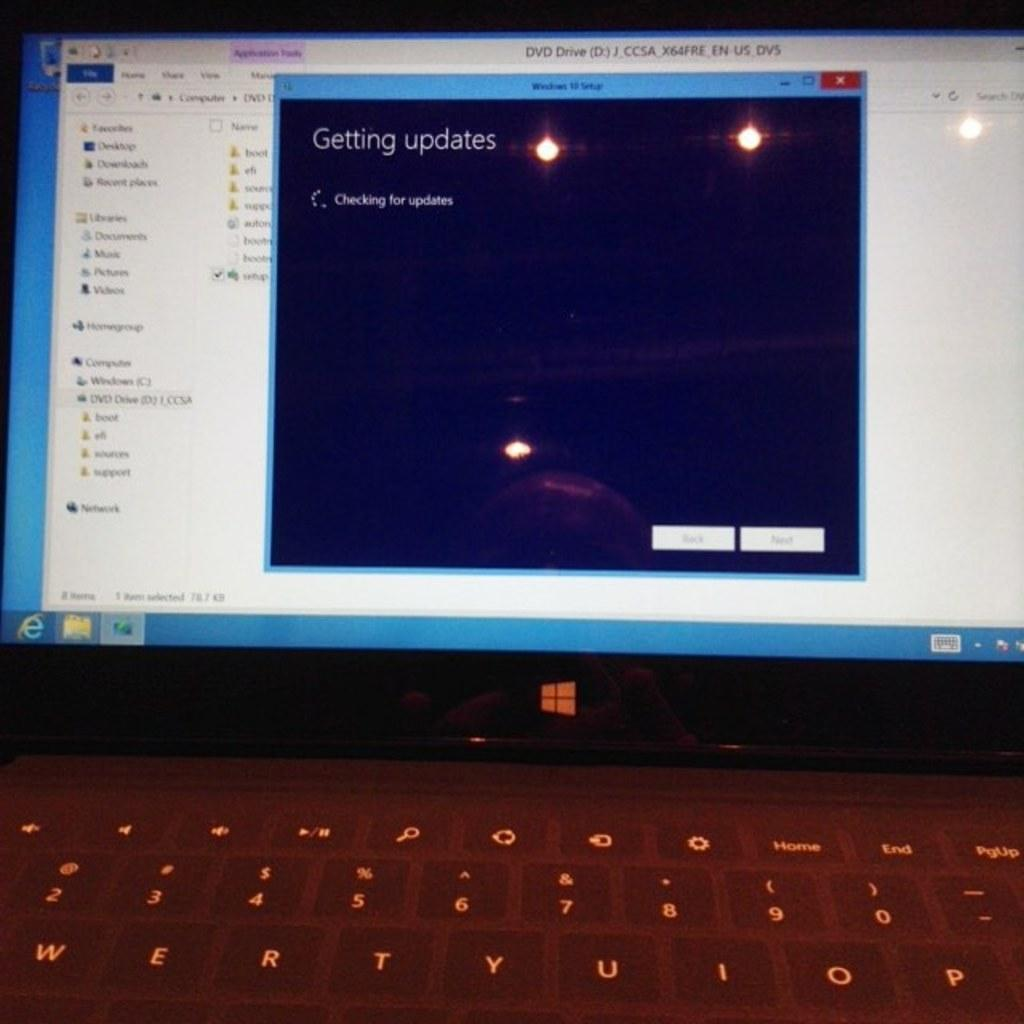<image>
Write a terse but informative summary of the picture. The computer is currently checking to find updates. 